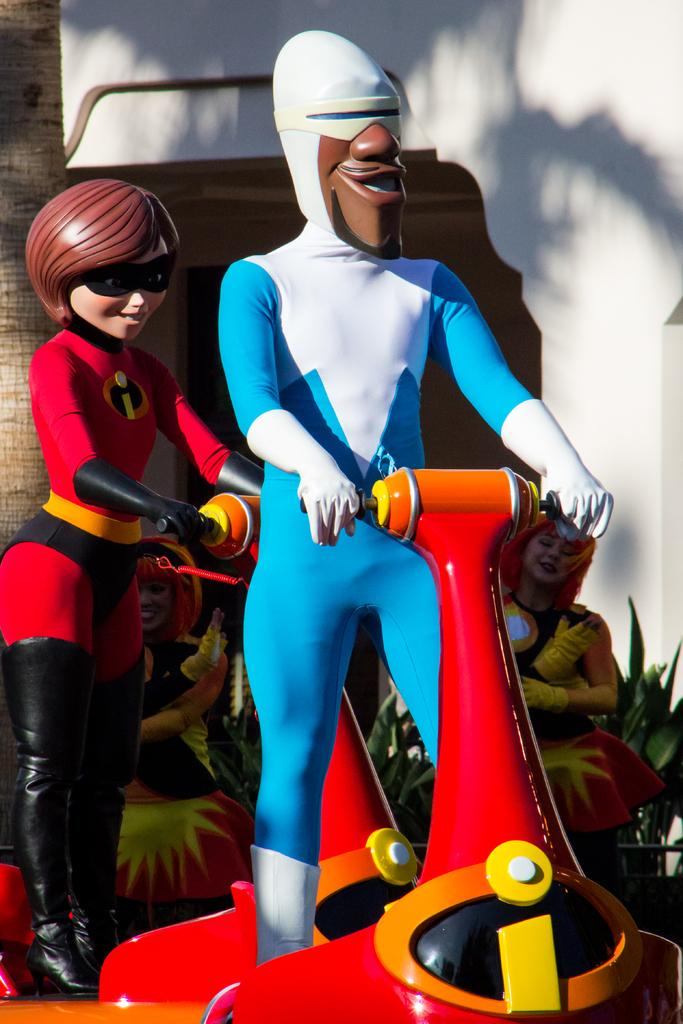What is located in the center of the image? There are toys in the center of the image. What can be seen in the background of the image? There are ladies standing and a wall visible in the background of the image. What type of vegetation is visible in the background of the image? There is a tree visible in the background of the image. What type of vest is hanging on the tree in the image? There is no vest present in the image; it only features toys, ladies, a wall, and a tree in the background. 